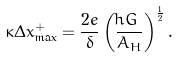<formula> <loc_0><loc_0><loc_500><loc_500>\kappa \Delta x _ { \max } ^ { + } = { \frac { 2 e } { \delta } } \left ( { \frac { \hbar { G } } { A _ { H } } } \right ) ^ { \frac { 1 } { 2 } } .</formula> 